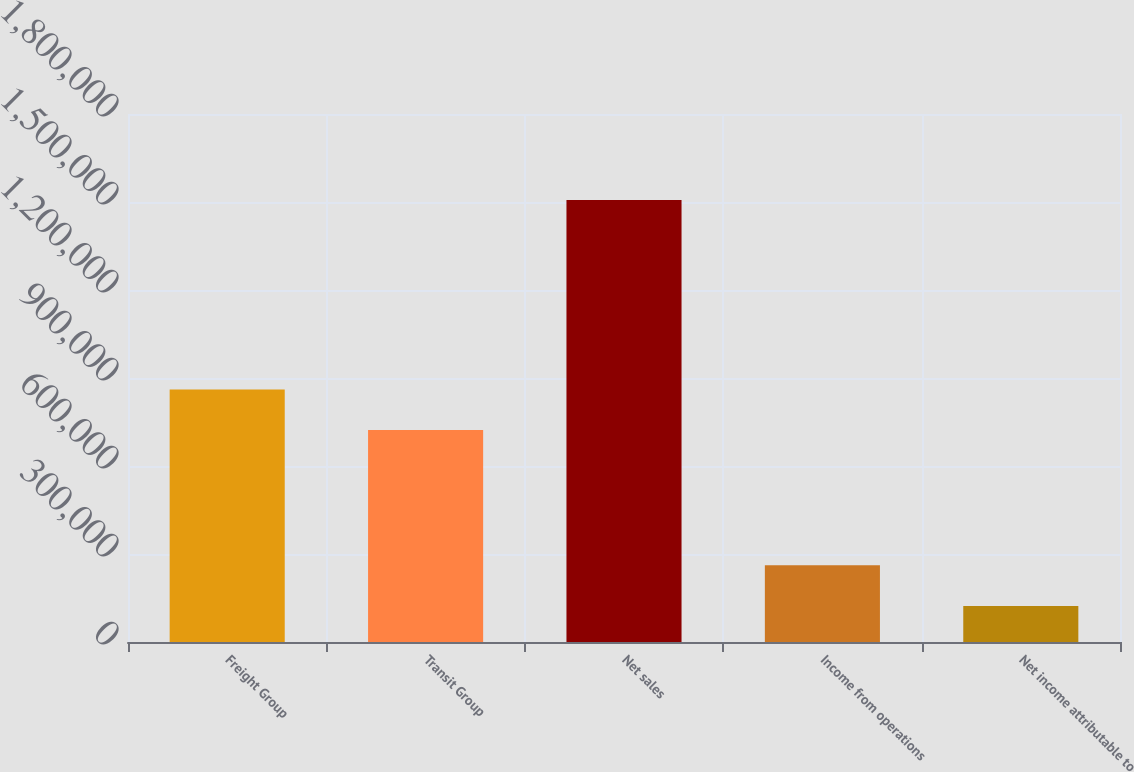Convert chart. <chart><loc_0><loc_0><loc_500><loc_500><bar_chart><fcel>Freight Group<fcel>Transit Group<fcel>Net sales<fcel>Income from operations<fcel>Net income attributable to<nl><fcel>860899<fcel>722508<fcel>1.50701e+06<fcel>261490<fcel>123099<nl></chart> 